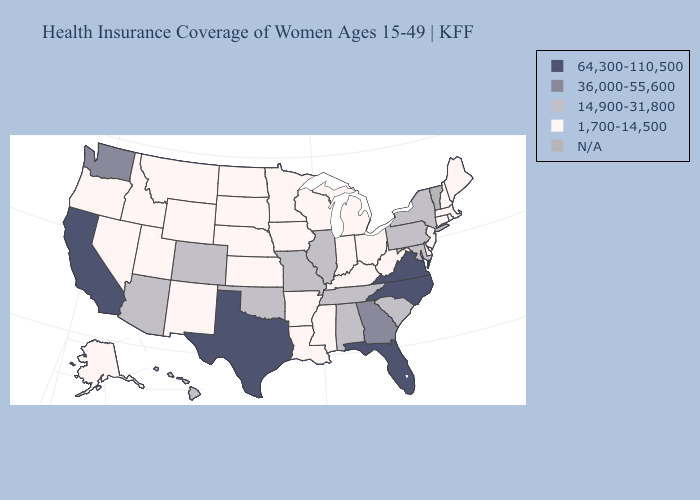Which states hav the highest value in the West?
Answer briefly. California. Does Utah have the highest value in the USA?
Be succinct. No. What is the highest value in the MidWest ?
Write a very short answer. 14,900-31,800. What is the value of Missouri?
Answer briefly. 14,900-31,800. Among the states that border New Mexico , does Texas have the highest value?
Answer briefly. Yes. Is the legend a continuous bar?
Be succinct. No. Which states have the highest value in the USA?
Concise answer only. California, Florida, North Carolina, Texas, Virginia. What is the lowest value in the MidWest?
Answer briefly. 1,700-14,500. Name the states that have a value in the range N/A?
Concise answer only. Vermont. Name the states that have a value in the range N/A?
Give a very brief answer. Vermont. What is the lowest value in the MidWest?
Short answer required. 1,700-14,500. How many symbols are there in the legend?
Write a very short answer. 5. What is the value of New Jersey?
Short answer required. 1,700-14,500. 